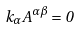<formula> <loc_0><loc_0><loc_500><loc_500>k _ { \alpha } A ^ { \alpha \beta } = 0</formula> 